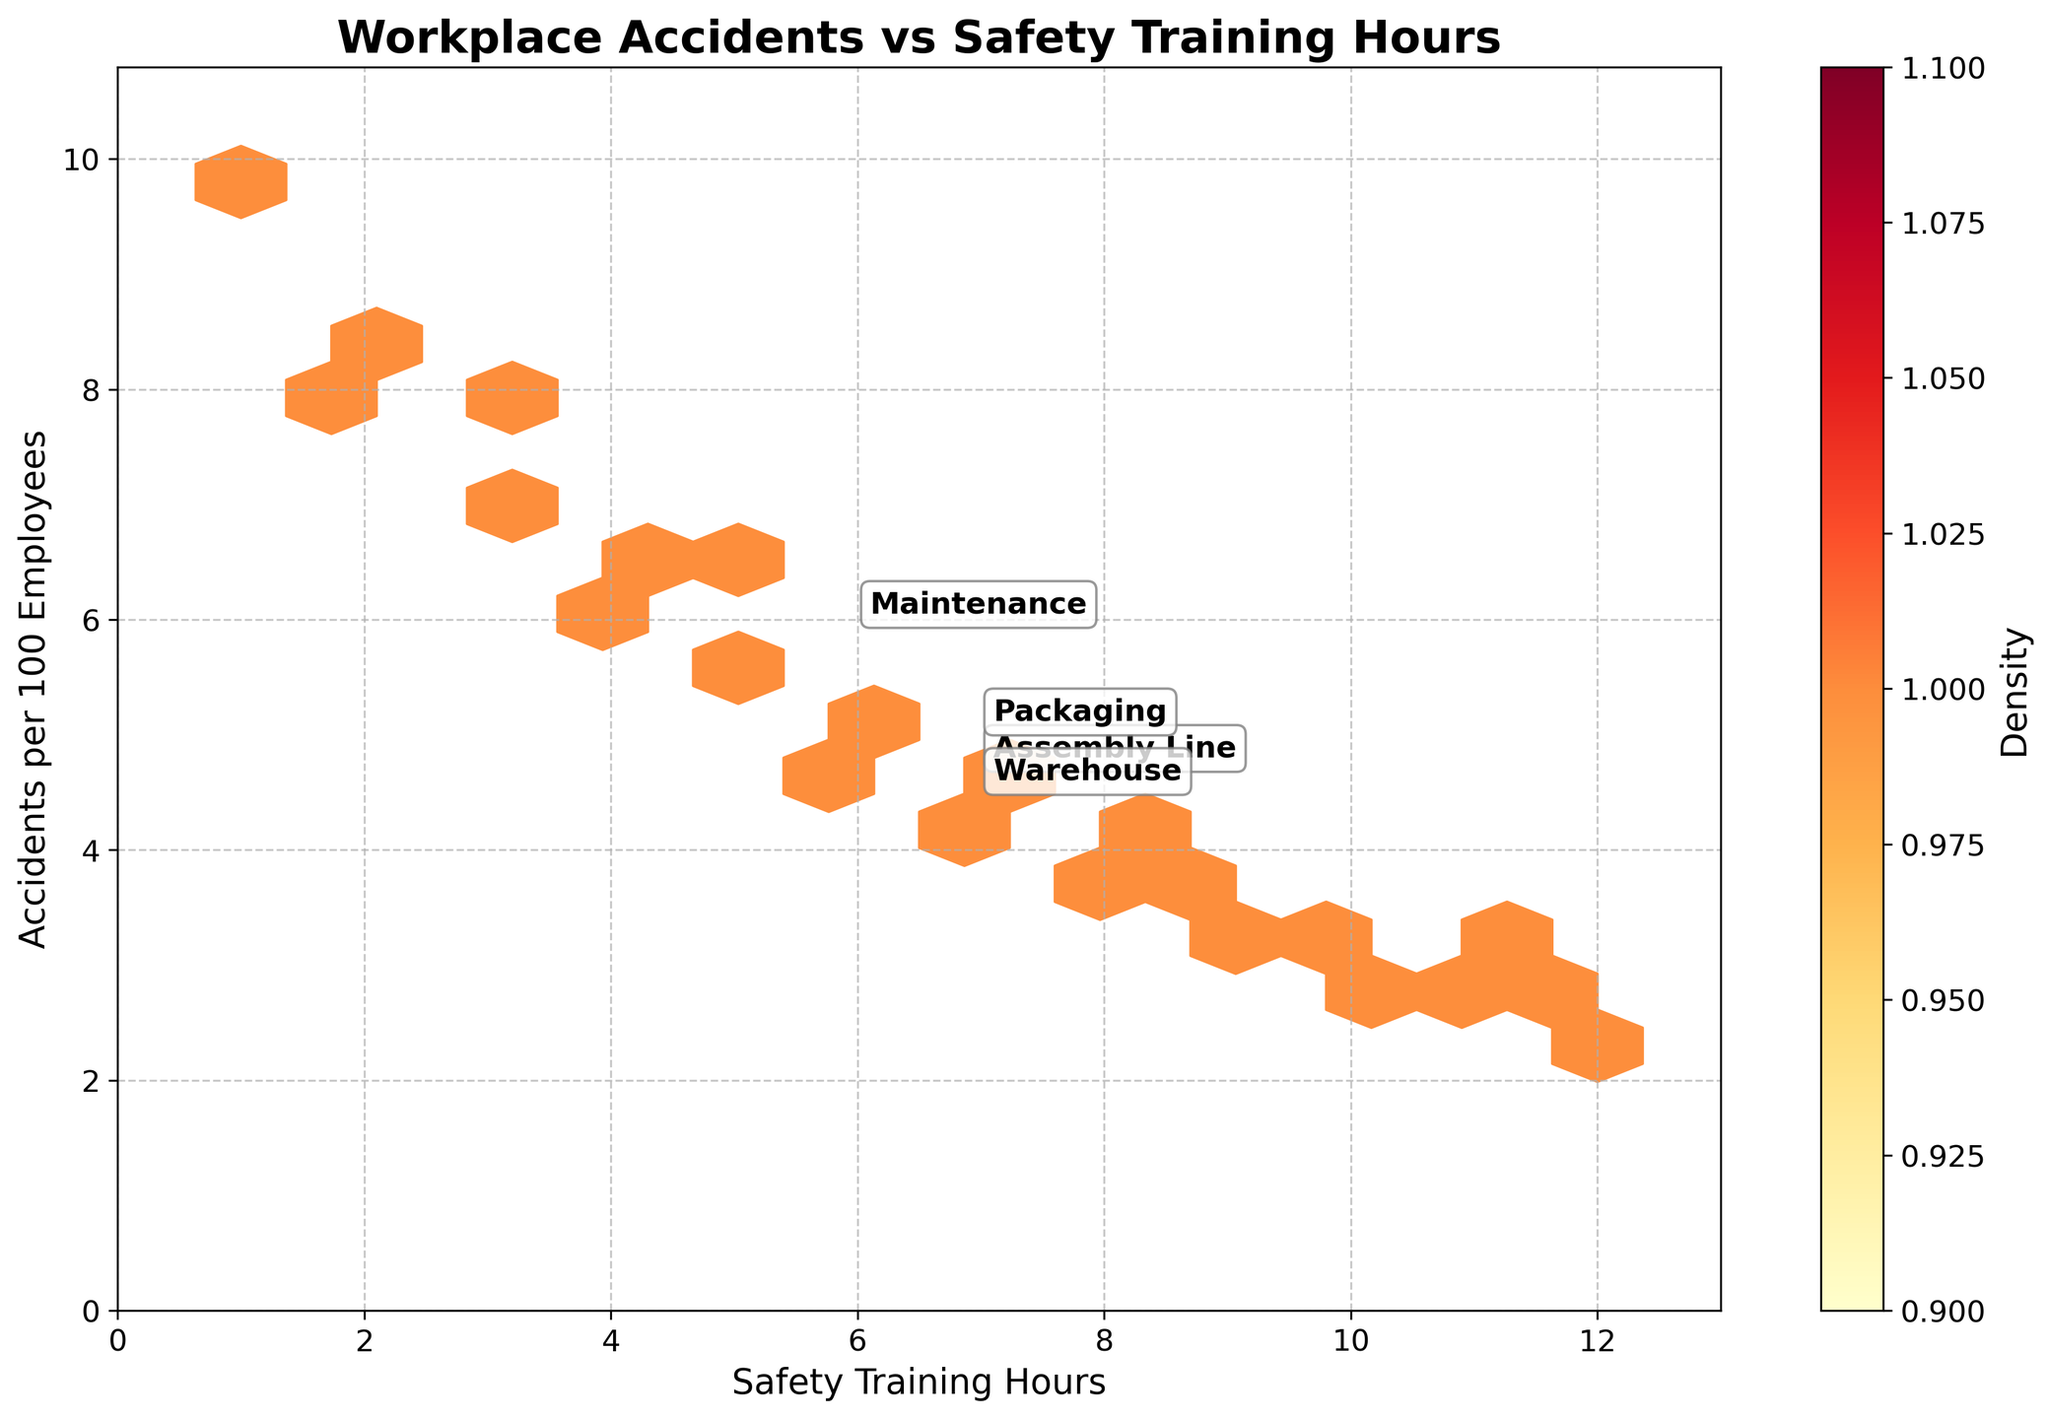What is the title of the plot? The title of the plot is prominently displayed at the top of the figure. The title reads "Workplace Accidents vs Safety Training Hours".
Answer: Workplace Accidents vs Safety Training Hours How many safety training hours correspond to the highest density of accidents per 100 employees? By examining the color density in the hexbin plot, the highest density of accidents (most clustered) appear to be around 3-6 safety training hours.
Answer: 3-6 hours What is the color of the hexagons representing the lowest density? The hexagons representing the lowest density are the lightest color in the "YlOrRd" colormap, which is a very light yellow.
Answer: Light yellow Which department appears to have the lowest average accidents per 100 employees? From the annotations on the plot, the department with the lowest average accidents per 100 employees can be identified by the position of their label. The department labeled "Assembly Line" is positioned the lowest on the plot.
Answer: Assembly Line What is the range of safety training hours represented on the x-axis? The x-axis is labeled "Safety Training Hours", and it spans from 0 to one unit above the maximum training hours in the data (12 hours), hence from 0 to 13.
Answer: 0 to 13 If we increase the safety training hours from 2 to 6, how does the average number of accidents per 100 employees change for the Assembly Line department? The accidents per 100 employees at 2 hours are 8.5, and at 6 hours are 4.8. The change is 8.5 - 4.8 = 3.7 fewer accidents per 100 employees.
Answer: 3.7 fewer accidents Which two departments have overlapping ranges of average safety training hours? Comparing the positions of department labels, "Warehouse" and "Maintenance" both have average safety training hours near the middle of the x-axis, showing some overlap.
Answer: Warehouse and Maintenance How does the relationship between safety training hours and accidents look overall in the plot? The plot shows a general downward trend, indicating that as safety training hours increase, the number of accidents per 100 employees decreases. This can be observed by the positioning of more densely colored hexagons toward the bottom right of the plot.
Answer: Decreasing trend What specific annotation helps identify the location of the average data point for each department on the plot? The plot includes text annotations that indicate the name of each department, placed at their respective average data points. These annotations help in identifying specific locations.
Answer: Text annotations 